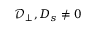<formula> <loc_0><loc_0><loc_500><loc_500>{ \mathcal { D } _ { \perp } } , { D _ { s } } \ne 0</formula> 